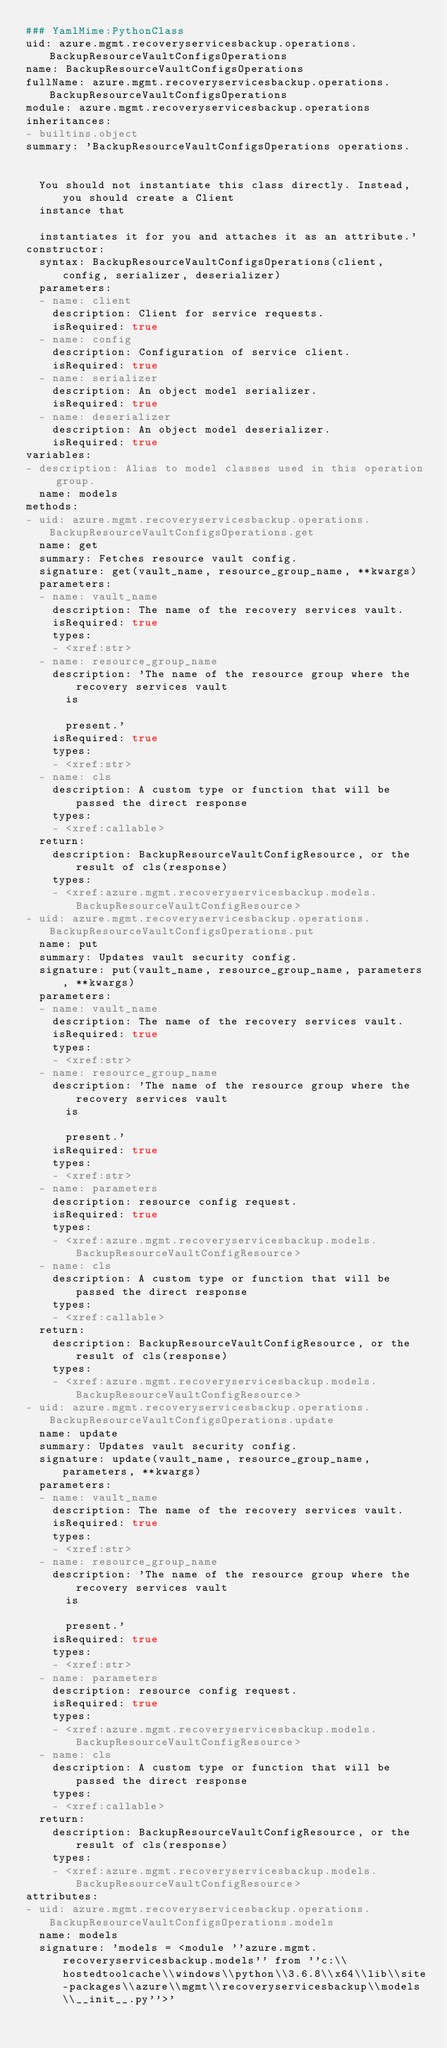Convert code to text. <code><loc_0><loc_0><loc_500><loc_500><_YAML_>### YamlMime:PythonClass
uid: azure.mgmt.recoveryservicesbackup.operations.BackupResourceVaultConfigsOperations
name: BackupResourceVaultConfigsOperations
fullName: azure.mgmt.recoveryservicesbackup.operations.BackupResourceVaultConfigsOperations
module: azure.mgmt.recoveryservicesbackup.operations
inheritances:
- builtins.object
summary: 'BackupResourceVaultConfigsOperations operations.


  You should not instantiate this class directly. Instead, you should create a Client
  instance that

  instantiates it for you and attaches it as an attribute.'
constructor:
  syntax: BackupResourceVaultConfigsOperations(client, config, serializer, deserializer)
  parameters:
  - name: client
    description: Client for service requests.
    isRequired: true
  - name: config
    description: Configuration of service client.
    isRequired: true
  - name: serializer
    description: An object model serializer.
    isRequired: true
  - name: deserializer
    description: An object model deserializer.
    isRequired: true
variables:
- description: Alias to model classes used in this operation group.
  name: models
methods:
- uid: azure.mgmt.recoveryservicesbackup.operations.BackupResourceVaultConfigsOperations.get
  name: get
  summary: Fetches resource vault config.
  signature: get(vault_name, resource_group_name, **kwargs)
  parameters:
  - name: vault_name
    description: The name of the recovery services vault.
    isRequired: true
    types:
    - <xref:str>
  - name: resource_group_name
    description: 'The name of the resource group where the recovery services vault
      is

      present.'
    isRequired: true
    types:
    - <xref:str>
  - name: cls
    description: A custom type or function that will be passed the direct response
    types:
    - <xref:callable>
  return:
    description: BackupResourceVaultConfigResource, or the result of cls(response)
    types:
    - <xref:azure.mgmt.recoveryservicesbackup.models.BackupResourceVaultConfigResource>
- uid: azure.mgmt.recoveryservicesbackup.operations.BackupResourceVaultConfigsOperations.put
  name: put
  summary: Updates vault security config.
  signature: put(vault_name, resource_group_name, parameters, **kwargs)
  parameters:
  - name: vault_name
    description: The name of the recovery services vault.
    isRequired: true
    types:
    - <xref:str>
  - name: resource_group_name
    description: 'The name of the resource group where the recovery services vault
      is

      present.'
    isRequired: true
    types:
    - <xref:str>
  - name: parameters
    description: resource config request.
    isRequired: true
    types:
    - <xref:azure.mgmt.recoveryservicesbackup.models.BackupResourceVaultConfigResource>
  - name: cls
    description: A custom type or function that will be passed the direct response
    types:
    - <xref:callable>
  return:
    description: BackupResourceVaultConfigResource, or the result of cls(response)
    types:
    - <xref:azure.mgmt.recoveryservicesbackup.models.BackupResourceVaultConfigResource>
- uid: azure.mgmt.recoveryservicesbackup.operations.BackupResourceVaultConfigsOperations.update
  name: update
  summary: Updates vault security config.
  signature: update(vault_name, resource_group_name, parameters, **kwargs)
  parameters:
  - name: vault_name
    description: The name of the recovery services vault.
    isRequired: true
    types:
    - <xref:str>
  - name: resource_group_name
    description: 'The name of the resource group where the recovery services vault
      is

      present.'
    isRequired: true
    types:
    - <xref:str>
  - name: parameters
    description: resource config request.
    isRequired: true
    types:
    - <xref:azure.mgmt.recoveryservicesbackup.models.BackupResourceVaultConfigResource>
  - name: cls
    description: A custom type or function that will be passed the direct response
    types:
    - <xref:callable>
  return:
    description: BackupResourceVaultConfigResource, or the result of cls(response)
    types:
    - <xref:azure.mgmt.recoveryservicesbackup.models.BackupResourceVaultConfigResource>
attributes:
- uid: azure.mgmt.recoveryservicesbackup.operations.BackupResourceVaultConfigsOperations.models
  name: models
  signature: 'models = <module ''azure.mgmt.recoveryservicesbackup.models'' from ''c:\\hostedtoolcache\\windows\\python\\3.6.8\\x64\\lib\\site-packages\\azure\\mgmt\\recoveryservicesbackup\\models\\__init__.py''>'
</code> 